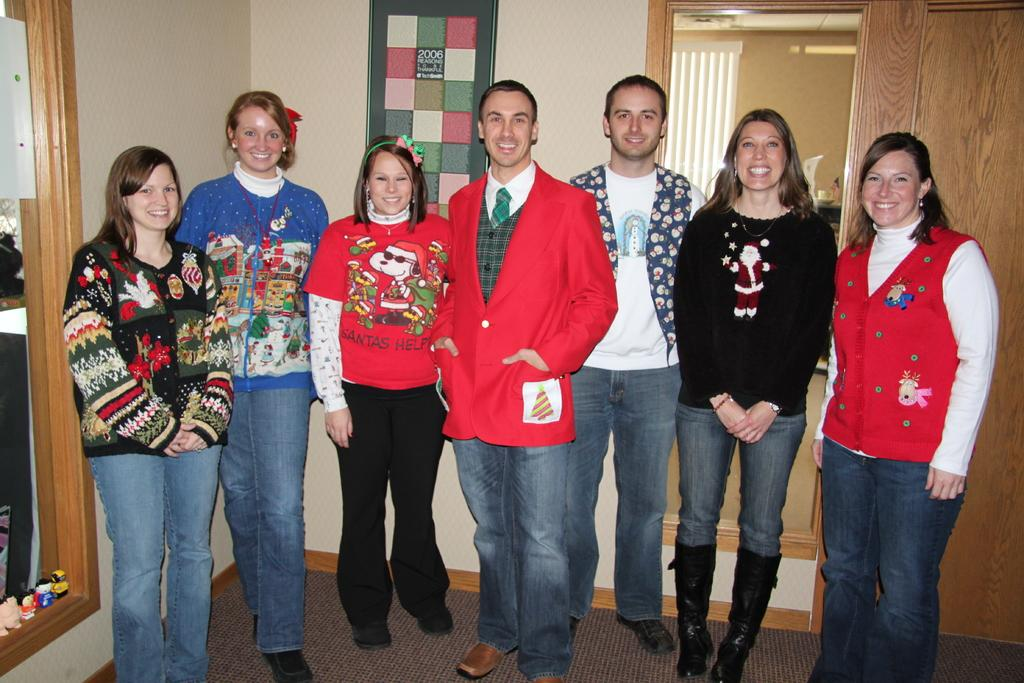What is happening in the middle of the image? There is a group of people in the middle of the image, and they are standing and laughing. What can be seen on the left side of the image? There appears to be a mirror on the left side of the image. What is located on the right side of the image? There is a door on the right side of the image. Can you see any airplanes in the image? No, there are no airplanes present in the image. Are the people in the image friends? We cannot definitively determine if the people in the image are friends based on the provided facts. 